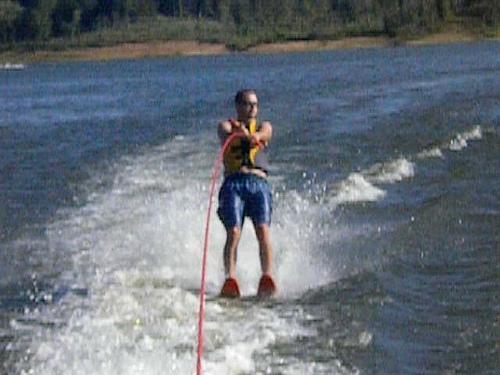How many men are in the picture?
Give a very brief answer. 1. 